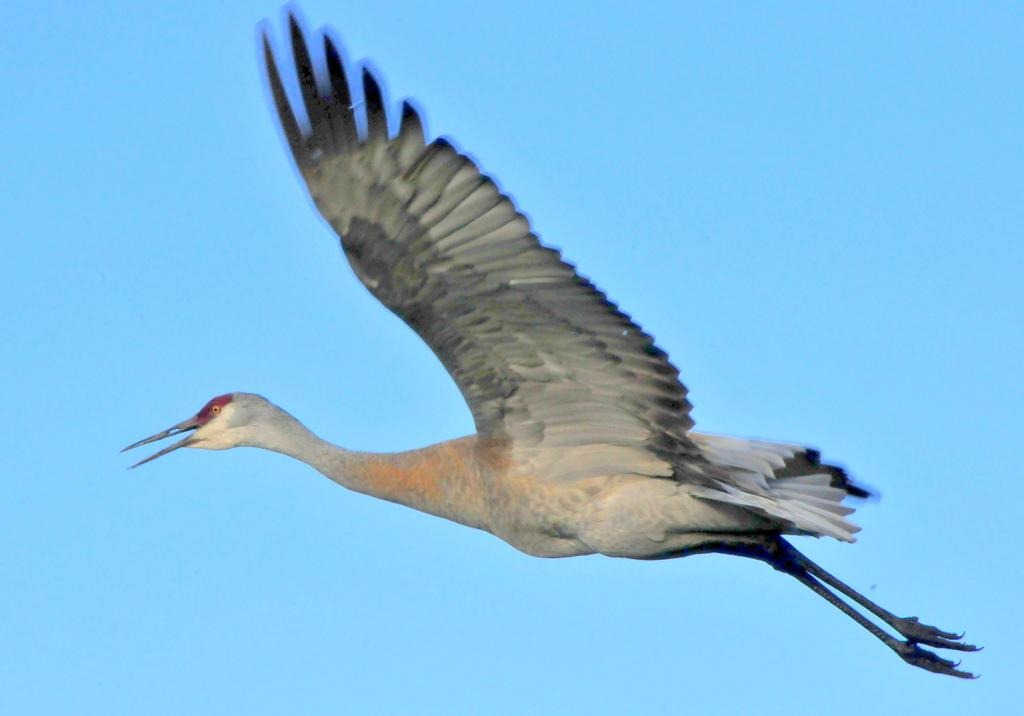What type of animal can be seen in the image? There is a bird in the image. What is the bird doing in the image? The bird is flying in the sky. What type of country is the bird flying over in the image? The image does not provide any information about the country or location where the bird is flying. 